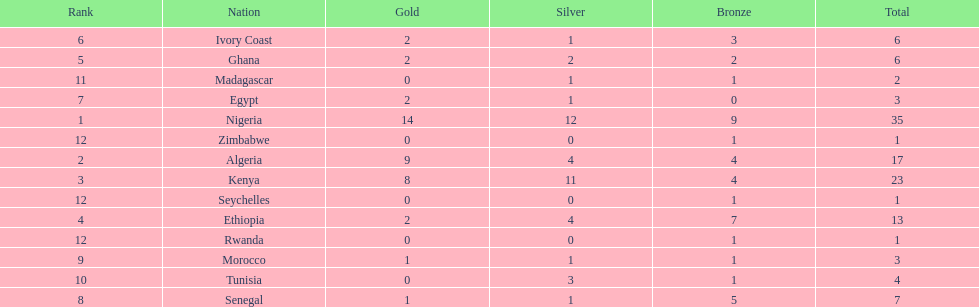Which nations have won only one medal? Rwanda, Zimbabwe, Seychelles. 